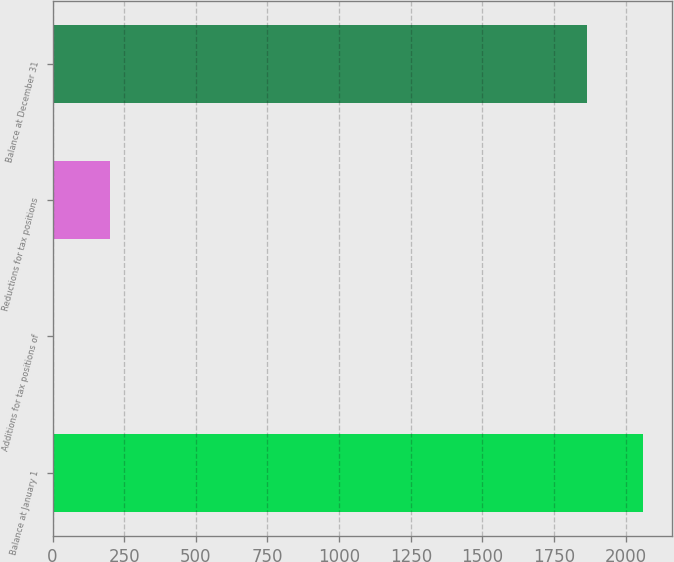<chart> <loc_0><loc_0><loc_500><loc_500><bar_chart><fcel>Balance at January 1<fcel>Additions for tax positions of<fcel>Reductions for tax positions<fcel>Balance at December 31<nl><fcel>2059.8<fcel>6<fcel>201.8<fcel>1864<nl></chart> 